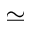<formula> <loc_0><loc_0><loc_500><loc_500>\simeq</formula> 